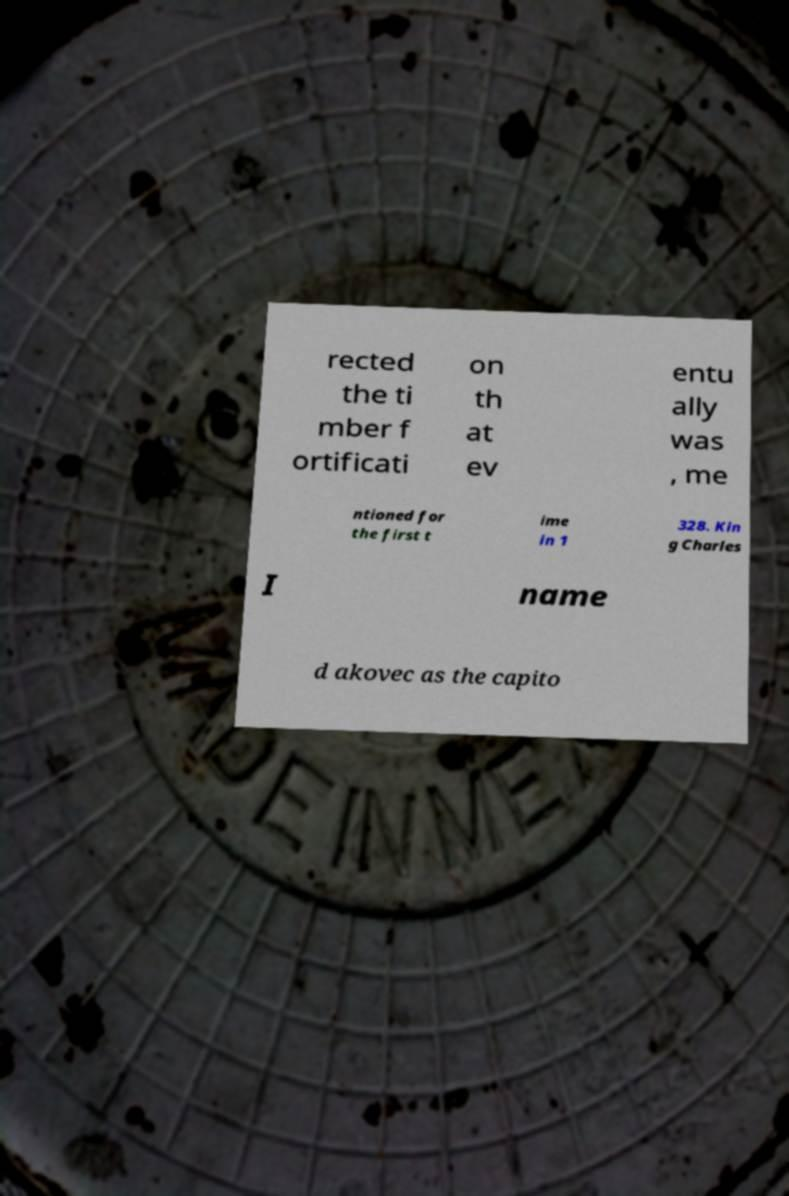There's text embedded in this image that I need extracted. Can you transcribe it verbatim? rected the ti mber f ortificati on th at ev entu ally was , me ntioned for the first t ime in 1 328. Kin g Charles I name d akovec as the capito 